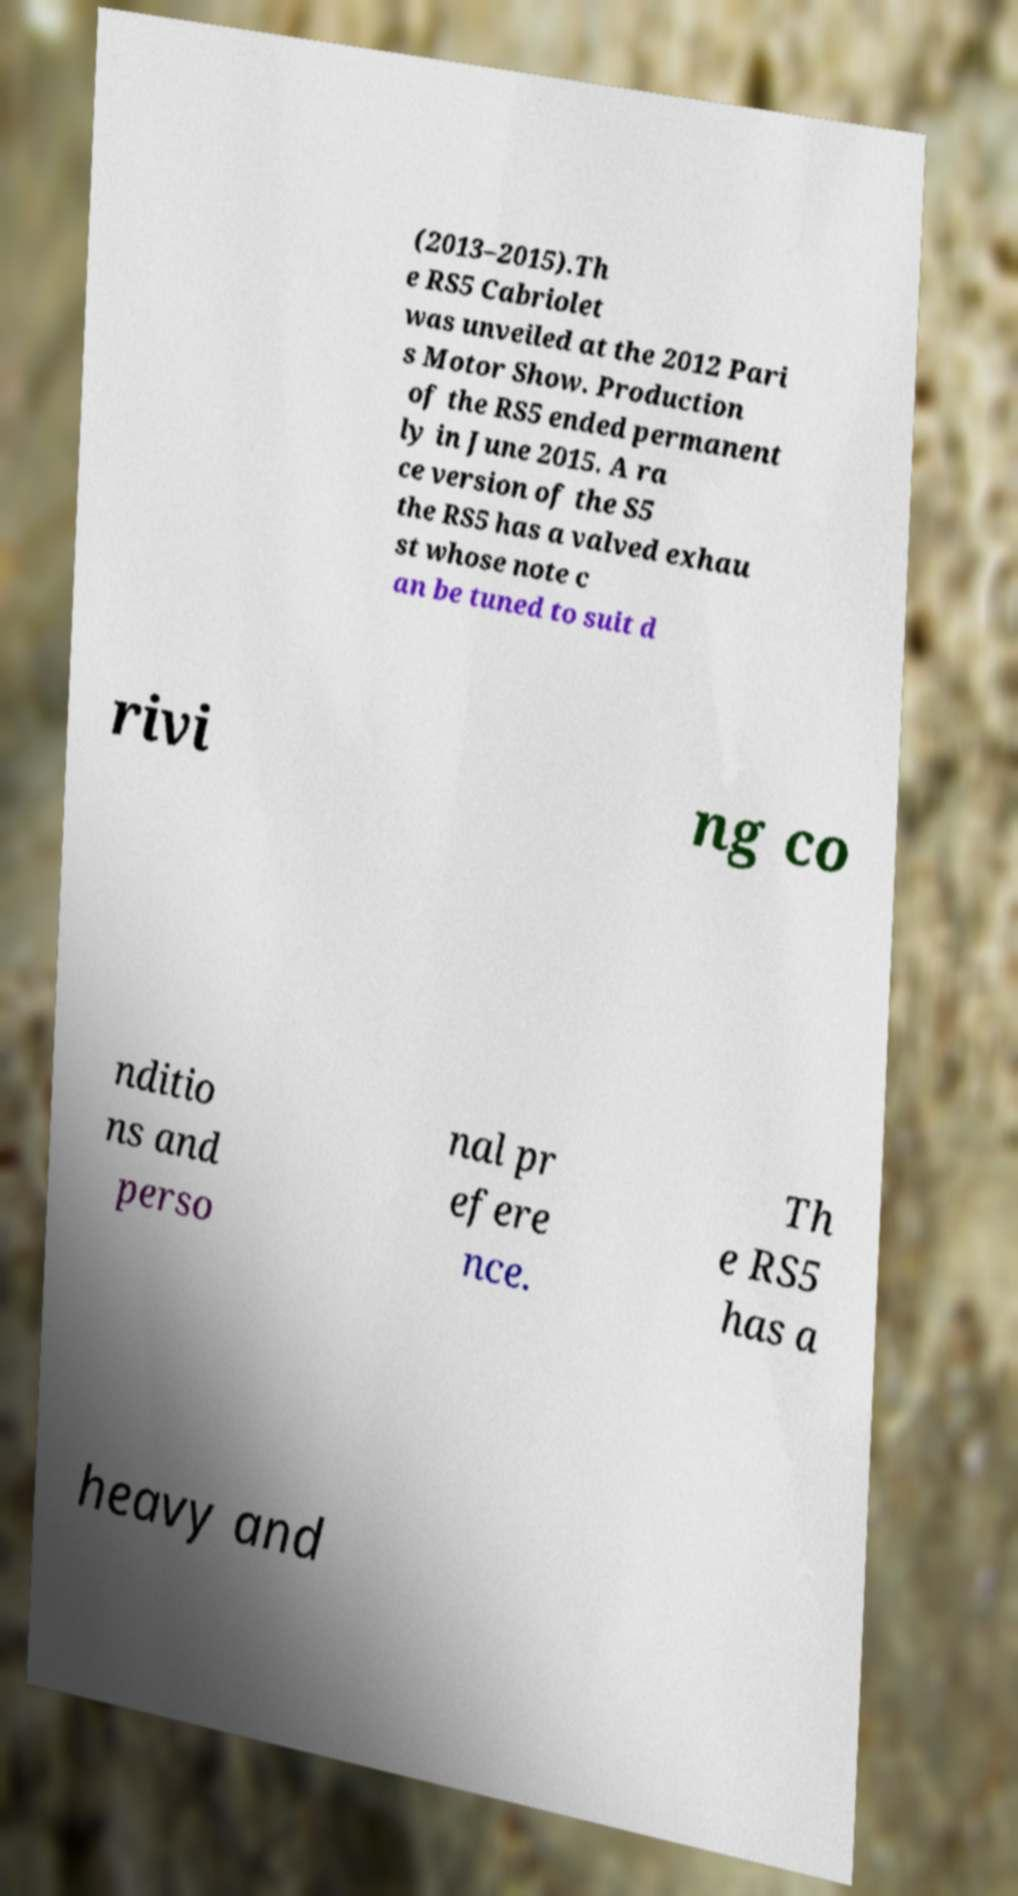Please read and relay the text visible in this image. What does it say? (2013–2015).Th e RS5 Cabriolet was unveiled at the 2012 Pari s Motor Show. Production of the RS5 ended permanent ly in June 2015. A ra ce version of the S5 the RS5 has a valved exhau st whose note c an be tuned to suit d rivi ng co nditio ns and perso nal pr efere nce. Th e RS5 has a heavy and 